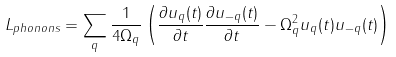Convert formula to latex. <formula><loc_0><loc_0><loc_500><loc_500>L _ { p h o n o n s } = \sum _ { q } \frac { 1 } { 4 \Omega _ { q } } \left ( \frac { \partial u _ { q } ( t ) } { \partial t } \frac { \partial u _ { - { q } } ( t ) } { \partial t } - \Omega ^ { 2 } _ { q } u _ { q } ( t ) u _ { - { q } } ( t ) \right )</formula> 